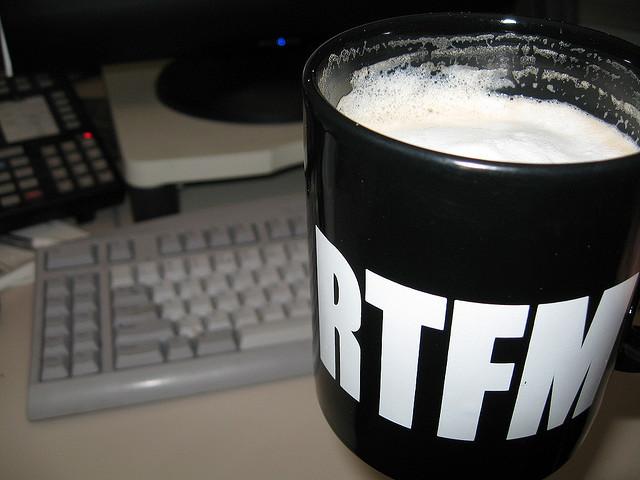Why is the light on the telephone red?
Be succinct. Hold. How many color lights do you see?
Write a very short answer. 2. What letters are on the cup?
Give a very brief answer. Rtfm. 